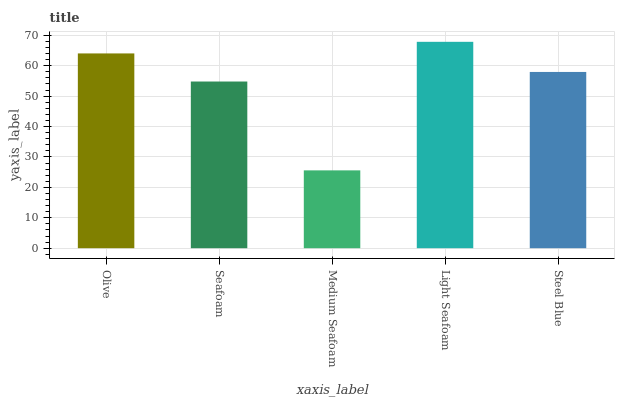Is Medium Seafoam the minimum?
Answer yes or no. Yes. Is Light Seafoam the maximum?
Answer yes or no. Yes. Is Seafoam the minimum?
Answer yes or no. No. Is Seafoam the maximum?
Answer yes or no. No. Is Olive greater than Seafoam?
Answer yes or no. Yes. Is Seafoam less than Olive?
Answer yes or no. Yes. Is Seafoam greater than Olive?
Answer yes or no. No. Is Olive less than Seafoam?
Answer yes or no. No. Is Steel Blue the high median?
Answer yes or no. Yes. Is Steel Blue the low median?
Answer yes or no. Yes. Is Light Seafoam the high median?
Answer yes or no. No. Is Light Seafoam the low median?
Answer yes or no. No. 